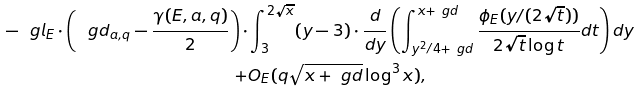Convert formula to latex. <formula><loc_0><loc_0><loc_500><loc_500>- \ g l _ { E } \cdot \left ( \ g d _ { a , q } - \frac { \gamma ( E , a , q ) } { 2 } \right ) \cdot & \int _ { 3 } ^ { 2 \sqrt { x } } ( y - 3 ) \cdot \frac { d } { d y } \left ( \int _ { y ^ { 2 } / 4 + \ g d } ^ { x + \ g d } \frac { \phi _ { E } ( y / ( 2 \sqrt { t } ) ) } { 2 \sqrt { t } \log t } d t \right ) d y \\ + & O _ { E } ( q \sqrt { x + \ g d } \log ^ { 3 } x ) ,</formula> 